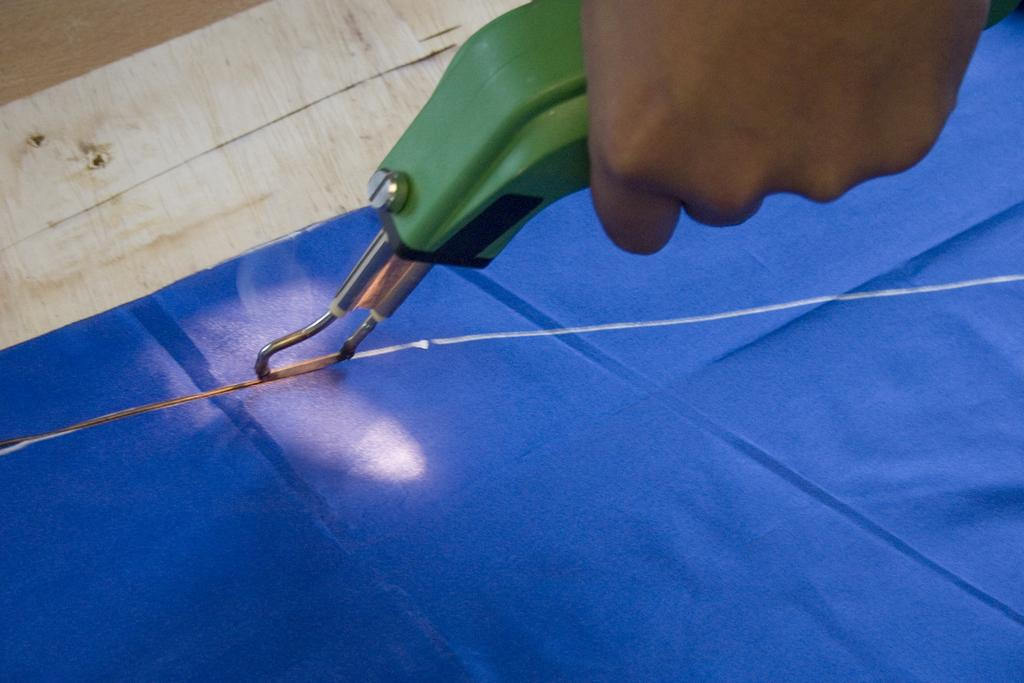Who is present in the image? There is a person in the image. What is the person doing in the image? The person is cutting a cloth. What tool is the person using to cut the cloth? The person is using a machine to cut the cloth. What type of jeans is the person wearing in the image? There is no information about the person's clothing in the image, so we cannot determine if they are wearing jeans or any other type of clothing. 